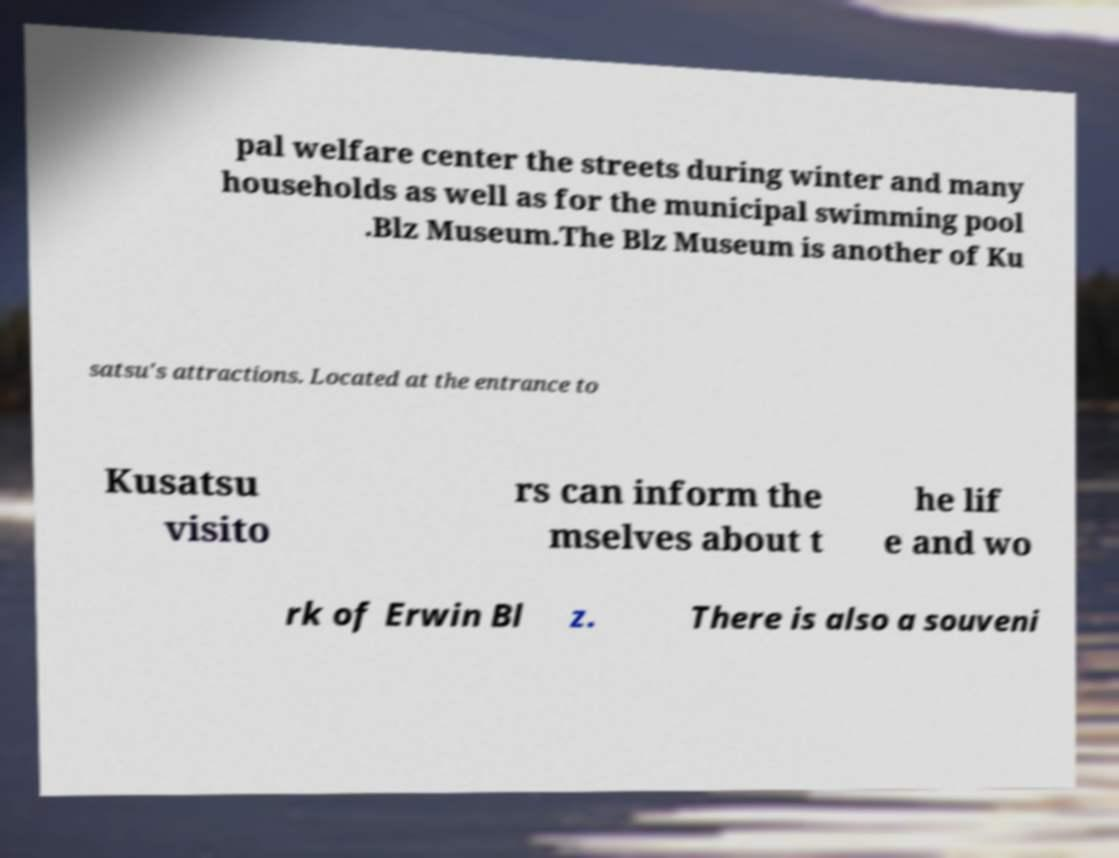I need the written content from this picture converted into text. Can you do that? pal welfare center the streets during winter and many households as well as for the municipal swimming pool .Blz Museum.The Blz Museum is another of Ku satsu's attractions. Located at the entrance to Kusatsu visito rs can inform the mselves about t he lif e and wo rk of Erwin Bl z. There is also a souveni 